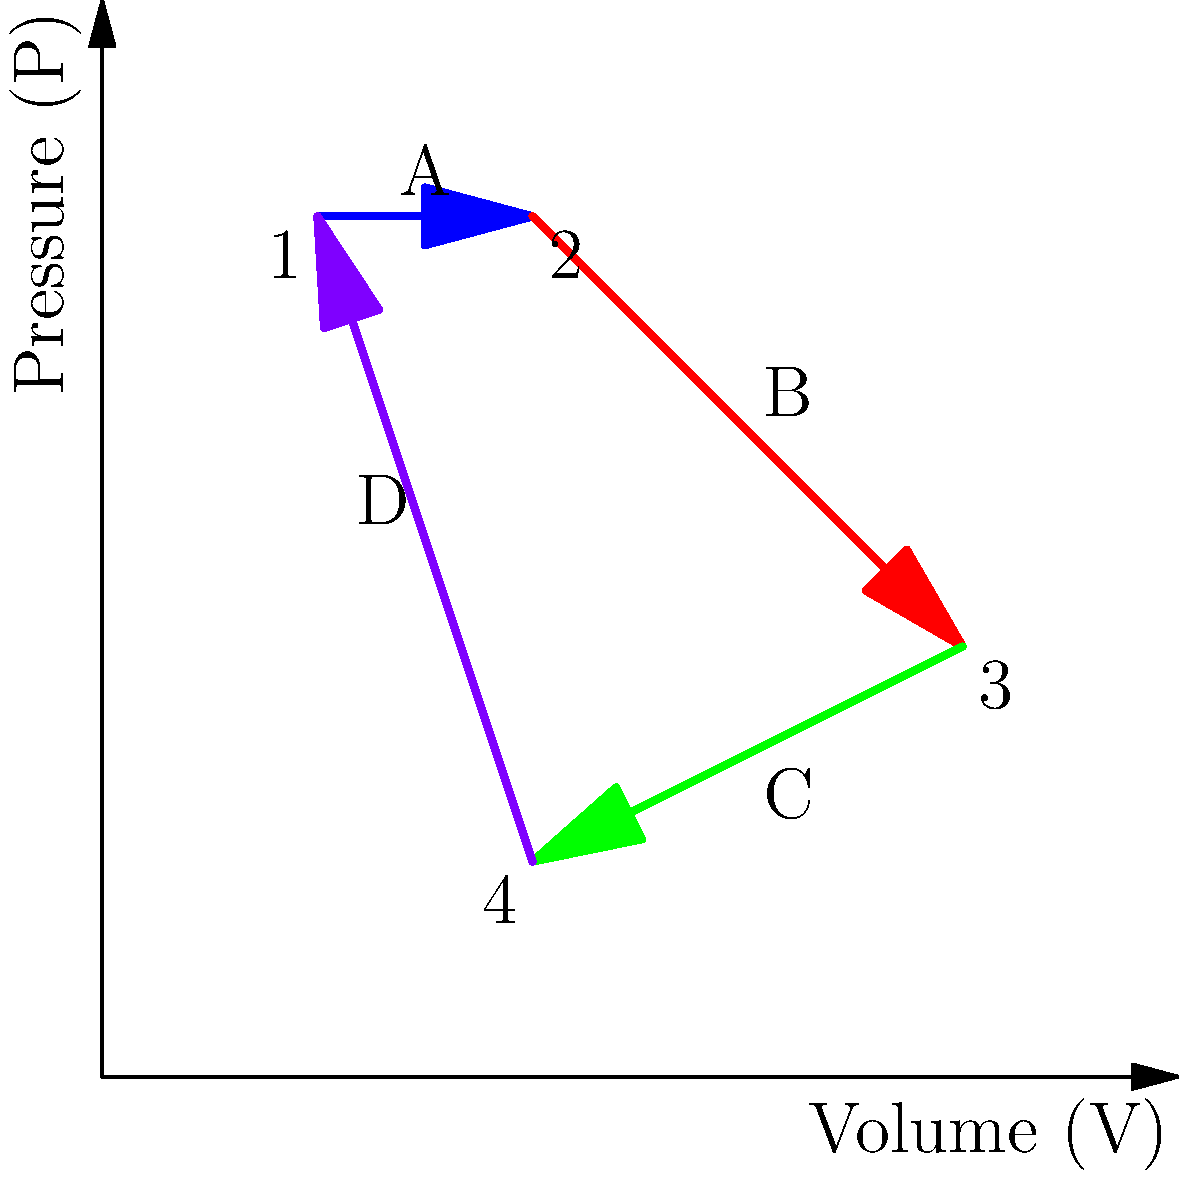As a financial advisor assessing a construction manager's retirement savings, you come across a thermodynamics problem related to potential energy savings in construction equipment. Analyze the pressure-volume (P-V) diagram of a thermodynamic cycle shown above. Which process in this cycle represents an isothermal expansion? To identify the isothermal expansion in the given P-V diagram, let's analyze each process:

1. Process A (1 to 2): This is a horizontal line, indicating constant pressure. This is not an isothermal expansion.

2. Process B (2 to 3): This is a curved line showing both pressure and volume changing. For an isothermal process, the relationship between P and V follows Boyle's Law: $PV = constant$. This curve appears to follow this relationship, as the product of P and V remains constant along the curve.

3. Process C (3 to 4): This is another curved line, but it's moving in the opposite direction of Process B. This is likely a compression, not an expansion.

4. Process D (4 to 1): This is a vertical line, indicating constant volume. This is not an expansion.

An isothermal expansion is characterized by:
a) An increase in volume
b) A decrease in pressure
c) Constant temperature (which results in $PV = constant$)

Process B (2 to 3) satisfies all these conditions. It shows an increase in volume, a decrease in pressure, and follows the $PV = constant$ curve, indicating constant temperature.

Therefore, Process B (2 to 3) represents an isothermal expansion.
Answer: Process B (2 to 3) 